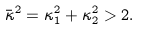Convert formula to latex. <formula><loc_0><loc_0><loc_500><loc_500>\bar { \kappa } ^ { 2 } = \kappa _ { 1 } ^ { 2 } + \kappa _ { 2 } ^ { 2 } > 2 .</formula> 